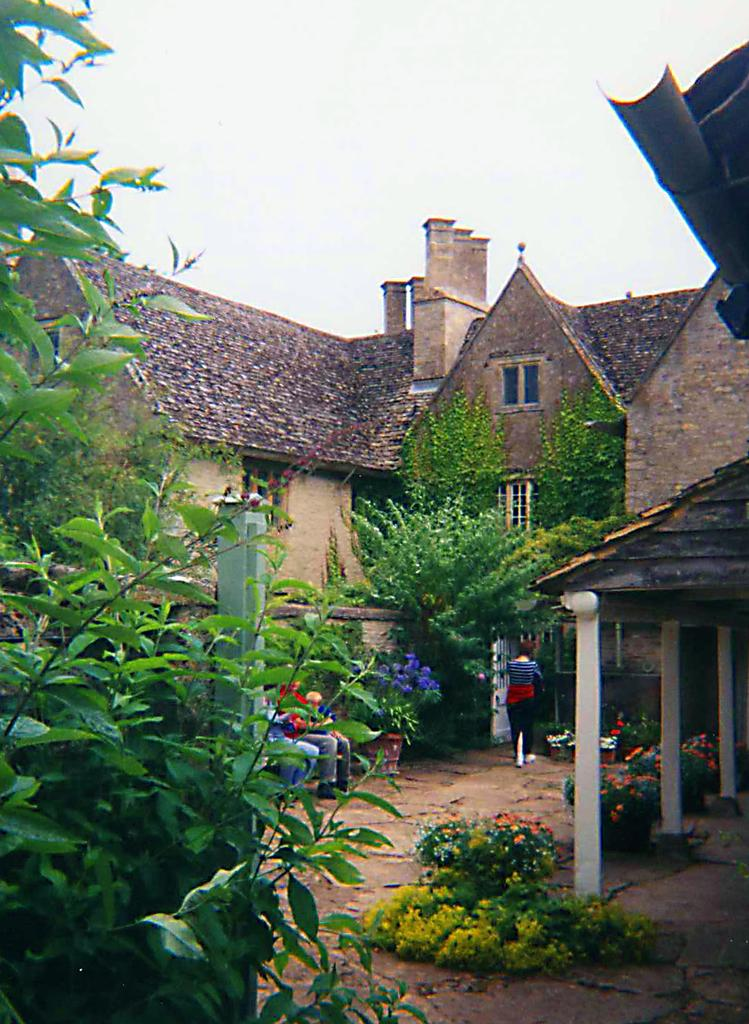What type of vegetation can be seen on the left side of the image? There are trees on the left side of the image. What structures are located in the middle of the image? There are houses in the middle of the image. What is visible at the top of the image? The sky is visible at the top of the image. What type of plants can be seen at the bottom of the image? Flower plants are present at the bottom of the image. How many stitches are required to sew the popcorn in the image? There is no popcorn or stitching present in the image. What is the amount of popcorn visible in the image? There is no popcorn present in the image. 